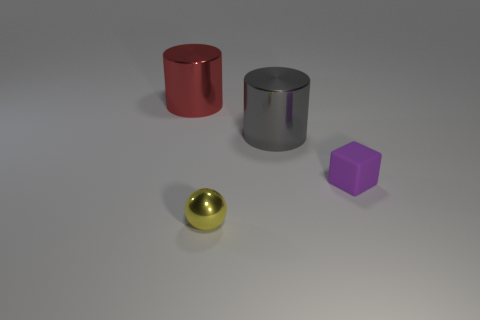Add 1 yellow spheres. How many objects exist? 5 Subtract all balls. How many objects are left? 3 Subtract all yellow balls. Subtract all big gray balls. How many objects are left? 3 Add 1 cylinders. How many cylinders are left? 3 Add 2 green rubber cubes. How many green rubber cubes exist? 2 Subtract 0 yellow cylinders. How many objects are left? 4 